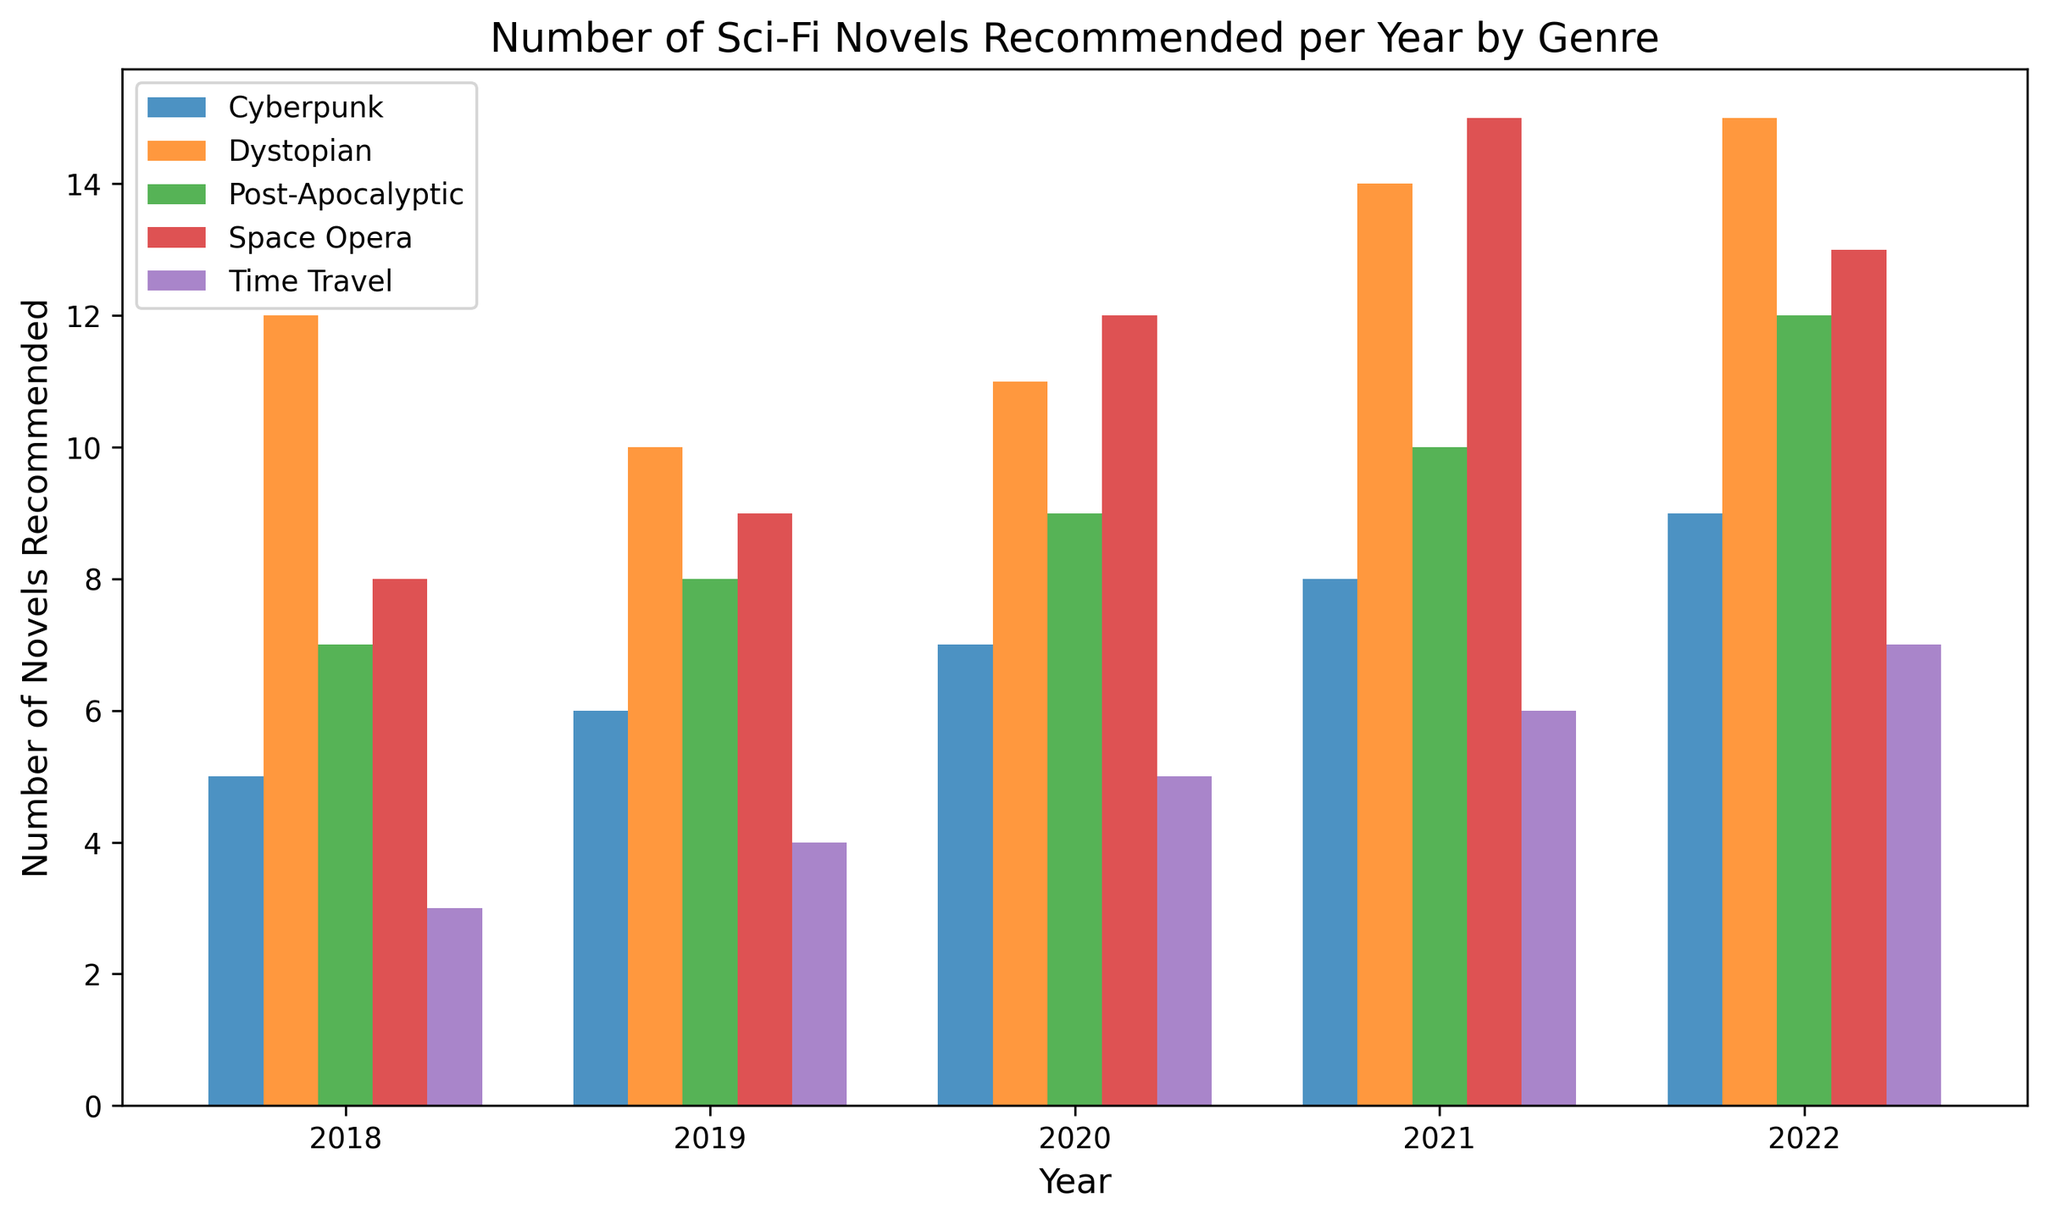Which genre had the highest number of novels recommended in 2018? To find the genre with the highest number of novels recommended in 2018, look at the bar heights for each genre in the 2018 section. Dystopian has the tallest bar.
Answer: Dystopian How does the number of Cyberpunk novels recommended in 2020 compare to 2019? Check the height of the bars for Cyberpunk in 2019 and 2020. In 2019, the number is 6, while in 2020, it is 7. Thus, 2020 had one more recommendation.
Answer: One more in 2020 Which year saw the highest number of Space Opera novels recommended? Compare the heights of Space Opera bars across all the years. 2021 has the tallest bar at 15 novels.
Answer: 2021 What is the average number of Dystopian novels recommended per year from 2018 to 2022? Add the number of Dystopian novels for each year (12+10+11+14+15) and then divide by 5. (Total = 62; Average = 62/5)
Answer: 12.4 Which genre shows the most significant increase in recommendations from 2018 to 2022? Calculate the difference between the values of each genre in 2022 and 2018: Cyberpunk (9-5=4), Space Opera (13-8=5), Dystopian (15-12=3), Time Travel (7-3=4), Post-Apocalyptic (12-7=5). Space Opera and Post-Apocalyptic both increased by 5, which is the highest.
Answer: Space Opera, Post-Apocalyptic In which year was the number of Time Travel novels recommended the lowest? Look for the shortest bar for Time Travel across all years. 2018 has the shortest bar at 3 novels.
Answer: 2018 Calculate the total number of novels recommended in 2021. Sum the numbers of novels recommended for each genre in 2021: Cyberpunk (8), Space Opera (15), Dystopian (14), Time Travel (6), Post-Apocalyptic (10). The total is 8+15+14+6+10.
Answer: 53 Is the number of Post-Apocalyptic novels recommended in 2022 higher or lower than in 2020? Compare the heights of the Post-Apocalyptic bars for 2020 and 2022. In 2020, it is 9; in 2022, it is 12. 2022 has more recommendations.
Answer: Higher in 2022 What is the difference in the number of novels recommended for Cyberpunk and Time Travel in 2022? Subtract the number for Time Travel from Cyberpunk in 2022. Cyberpunk has 9 and Time Travel has 7, so 9 - 7 = 2.
Answer: 2 